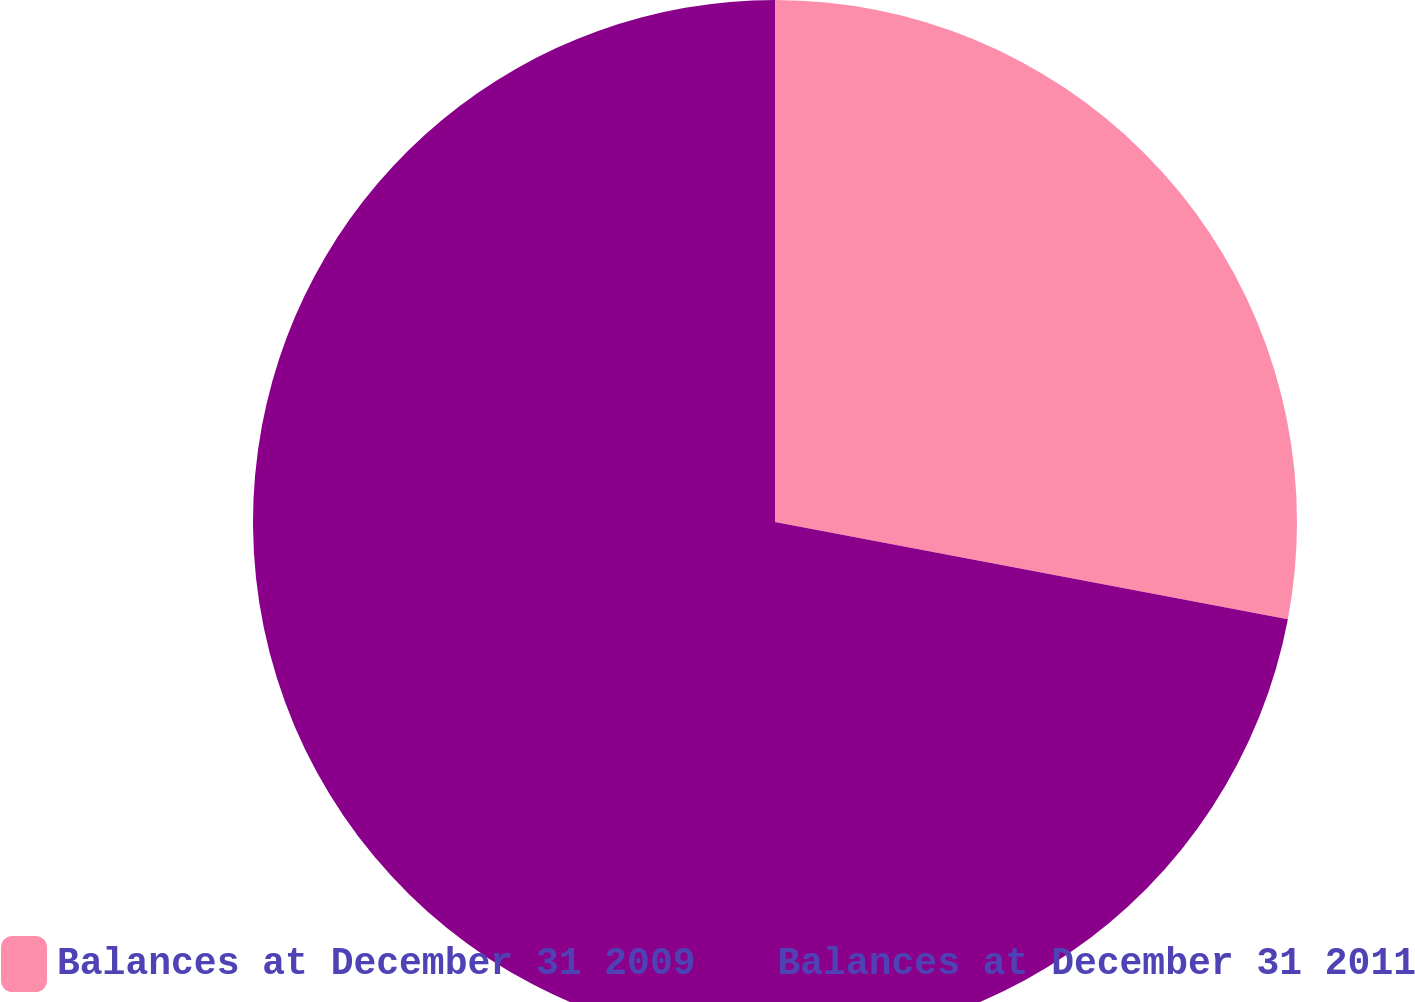Convert chart. <chart><loc_0><loc_0><loc_500><loc_500><pie_chart><fcel>Balances at December 31 2009<fcel>Balances at December 31 2011<nl><fcel>27.98%<fcel>72.02%<nl></chart> 